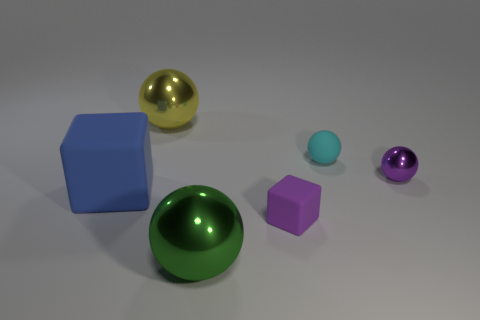There is a rubber object that is in front of the large rubber object; what size is it?
Your response must be concise. Small. There is a tiny purple thing left of the metal ball that is to the right of the cube right of the big yellow shiny object; what shape is it?
Keep it short and to the point. Cube. What is the shape of the shiny object that is behind the big blue matte block and on the left side of the small purple sphere?
Ensure brevity in your answer.  Sphere. Is there a blue rubber block of the same size as the blue matte thing?
Offer a very short reply. No. There is a large object behind the cyan rubber object; is it the same shape as the small purple matte thing?
Offer a very short reply. No. Is the large blue object the same shape as the tiny purple matte object?
Offer a terse response. Yes. Is there a small purple matte thing that has the same shape as the blue object?
Make the answer very short. Yes. What is the shape of the matte object that is left of the rubber block that is right of the large yellow metallic object?
Offer a very short reply. Cube. What is the color of the big sphere that is behind the green shiny sphere?
Your answer should be very brief. Yellow. There is a blue thing that is the same material as the cyan sphere; what size is it?
Make the answer very short. Large. 